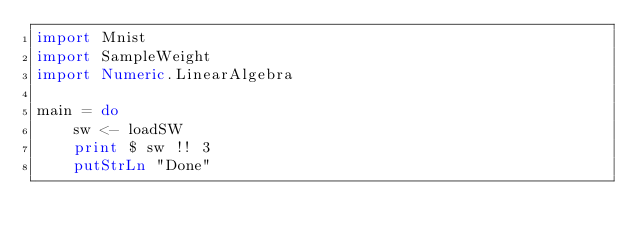<code> <loc_0><loc_0><loc_500><loc_500><_Haskell_>import Mnist
import SampleWeight
import Numeric.LinearAlgebra

main = do
    sw <- loadSW
    print $ sw !! 3
    putStrLn "Done"
</code> 